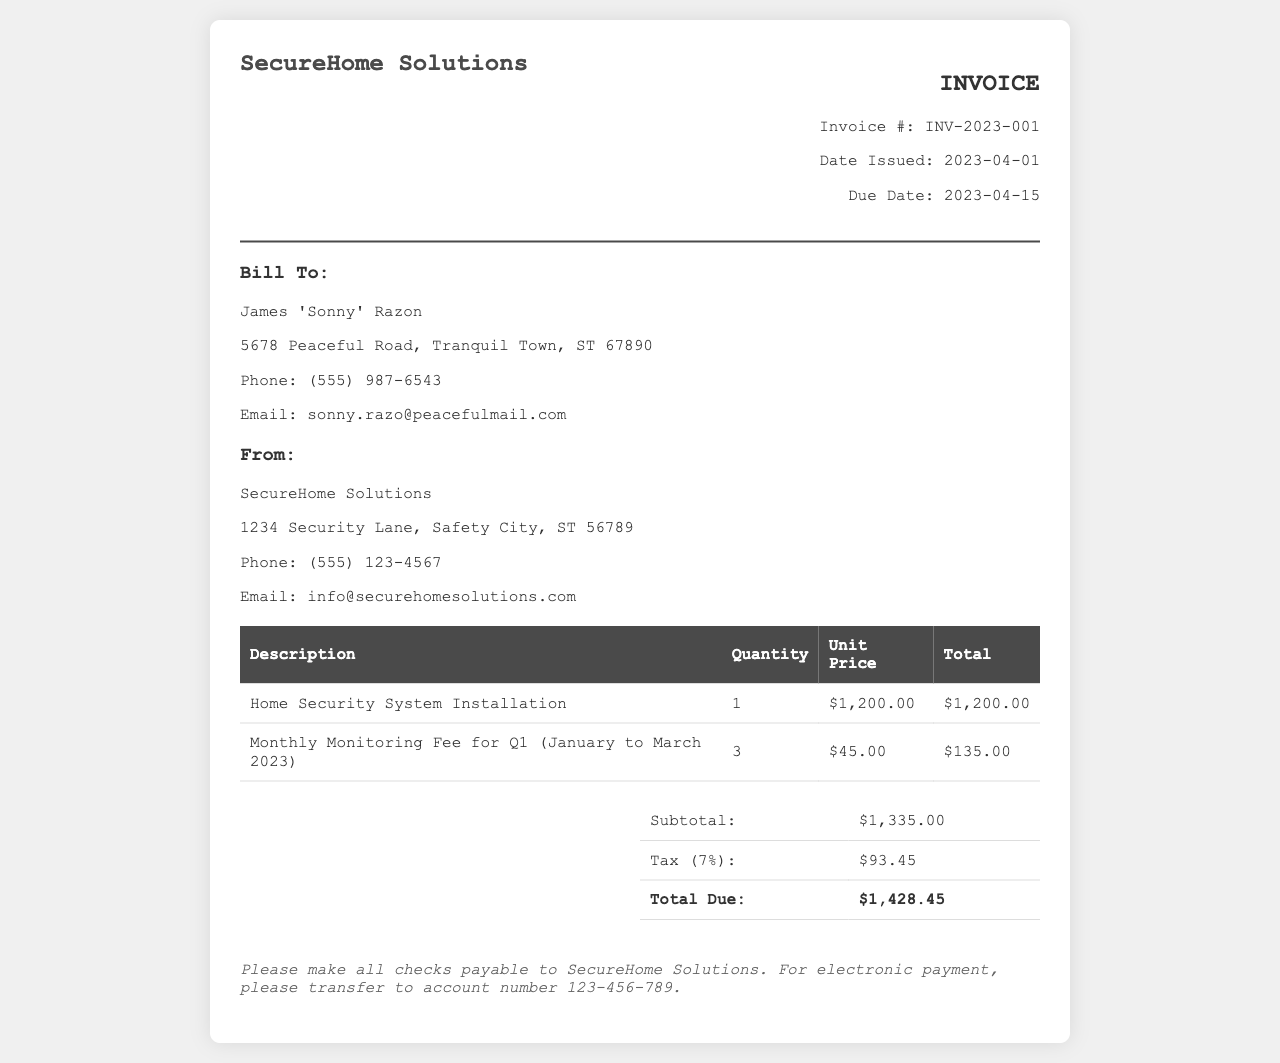What is the invoice number? The invoice number is explicitly stated in the document under "Invoice #."
Answer: INV-2023-001 What is the total amount due? The total amount due is provided in the summary section of the invoice.
Answer: $1,428.45 Who is the bill recipient? The bill recipient's name is listed in the "Bill To" section of the document.
Answer: James 'Sonny' Razon What is the installation cost? The installation cost is listed in the table detailing services provided.
Answer: $1,200.00 How many months are included in the monitoring fee for Q1? The monthly monitoring fee covers January to March, totaling three months.
Answer: 3 What is the tax percentage applied? The tax percentage can be found in the summary of the invoice.
Answer: 7% What is the date due for payment? The due date is indicated under the invoice details section.
Answer: 2023-04-15 What company issued the invoice? The issuing company is identified at the top of the invoice.
Answer: SecureHome Solutions What is the subtotal amount before tax? The subtotal is clearly stated before the total due in the summary.
Answer: $1,335.00 